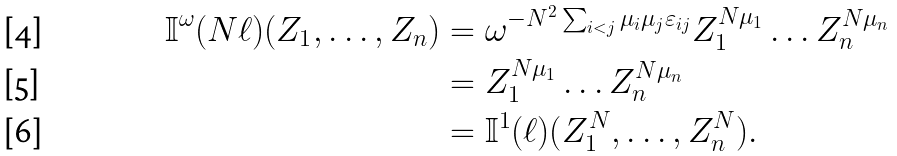<formula> <loc_0><loc_0><loc_500><loc_500>\mathbb { I } ^ { \omega } ( N \ell ) ( Z _ { 1 } , \dots , Z _ { n } ) & = \omega ^ { - N ^ { 2 } \sum _ { i < j } \mu _ { i } \mu _ { j } \varepsilon _ { i j } } Z _ { 1 } ^ { N \mu _ { 1 } } \dots Z _ { n } ^ { N \mu _ { n } } \\ & = Z _ { 1 } ^ { N \mu _ { 1 } } \dots Z _ { n } ^ { N \mu _ { n } } \\ & = \mathbb { I } ^ { 1 } ( \ell ) ( Z _ { 1 } ^ { N } , \dots , Z _ { n } ^ { N } ) .</formula> 